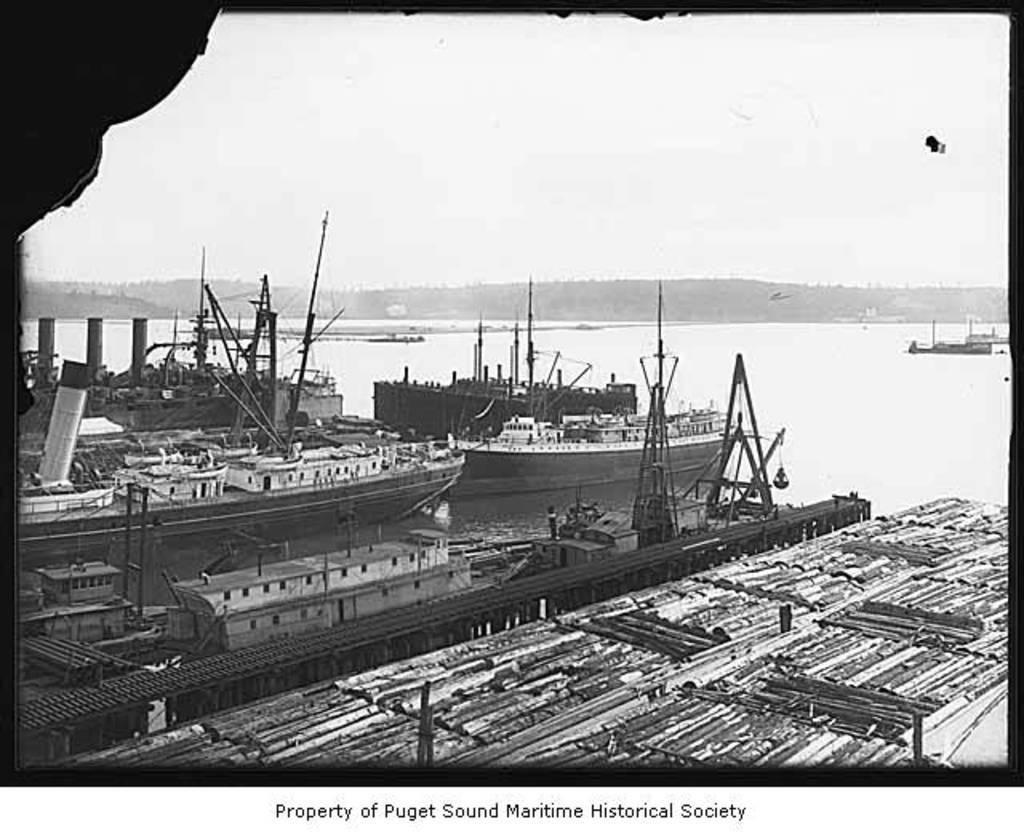How would you summarize this image in a sentence or two? It is a black and white picture. In this image, we can see ships, water, poles and few objects. Background we can see hills and sky. We can see text at the bottom of the image. 